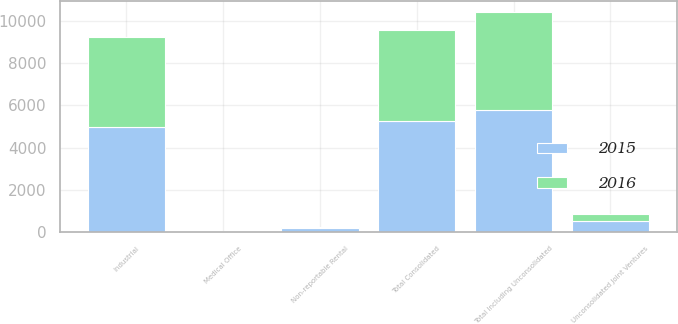<chart> <loc_0><loc_0><loc_500><loc_500><stacked_bar_chart><ecel><fcel>Industrial<fcel>Medical Office<fcel>Non-reportable Rental<fcel>Total Consolidated<fcel>Unconsolidated Joint Ventures<fcel>Total Including Unconsolidated<nl><fcel>2016<fcel>4246<fcel>17<fcel>46<fcel>4309<fcel>346<fcel>4655<nl><fcel>2015<fcel>4986<fcel>41<fcel>216<fcel>5243<fcel>515<fcel>5758<nl></chart> 